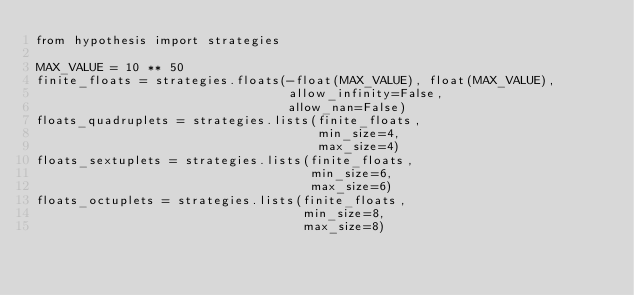<code> <loc_0><loc_0><loc_500><loc_500><_Python_>from hypothesis import strategies

MAX_VALUE = 10 ** 50
finite_floats = strategies.floats(-float(MAX_VALUE), float(MAX_VALUE),
                                  allow_infinity=False,
                                  allow_nan=False)
floats_quadruplets = strategies.lists(finite_floats,
                                      min_size=4,
                                      max_size=4)
floats_sextuplets = strategies.lists(finite_floats,
                                     min_size=6,
                                     max_size=6)
floats_octuplets = strategies.lists(finite_floats,
                                    min_size=8,
                                    max_size=8)
</code> 